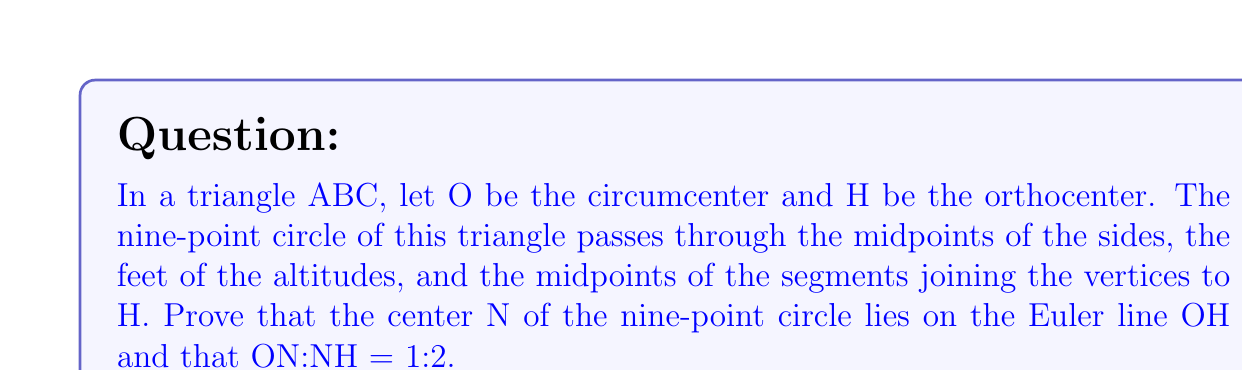Provide a solution to this math problem. Let's approach this proof step-by-step:

1) First, recall that the Euler line contains the centroid G, the orthocenter H, and the circumcenter O of a triangle.

2) The nine-point circle is so named because it passes through nine significant points of the triangle:
   - The midpoints of the three sides
   - The feet of the three altitudes
   - The midpoints of the segments from each vertex to the orthocenter

3) Let's consider the midpoints of the sides. These form a medial triangle, which is similar to the original triangle with a scale factor of 1:2.

4) The circumcenter of this medial triangle is the center N of the nine-point circle.

5) Since the medial triangle is similar to the original with scale factor 1:2, its circumcenter N divides the segment OH in the ratio 1:2.

6) To prove this rigorously:
   Let M be the midpoint of side BC. 
   $$\overrightarrow{OM} = \frac{1}{2}(\overrightarrow{OB} + \overrightarrow{OC})$$

7) The vector from O to N is the average of the vectors from O to all points on the nine-point circle. For the midpoints of the sides:
   $$\overrightarrow{ON} = \frac{1}{3}(\overrightarrow{OM_1} + \overrightarrow{OM_2} + \overrightarrow{OM_3})$$
   where $M_1$, $M_2$, and $M_3$ are the midpoints of the sides.

8) Substituting the result from step 6:
   $$\overrightarrow{ON} = \frac{1}{3} \cdot \frac{1}{2}(\overrightarrow{OA} + \overrightarrow{OB} + \overrightarrow{OC}) = \frac{1}{6}(\overrightarrow{OA} + \overrightarrow{OB} + \overrightarrow{OC})$$

9) The centroid G divides each median in the ratio 2:1 from the vertex. Thus:
   $$\overrightarrow{OG} = \frac{1}{3}(\overrightarrow{OA} + \overrightarrow{OB} + \overrightarrow{OC})$$

10) Comparing the results from steps 8 and 9:
    $$\overrightarrow{ON} = \frac{1}{2}\overrightarrow{OG}$$

11) We know that G divides OH in the ratio 1:2. Combined with the result from step 10, this proves that N divides OH in the ratio 1:2.

Therefore, N lies on the Euler line OH and ON:NH = 1:2.
Answer: ON:NH = 1:2 